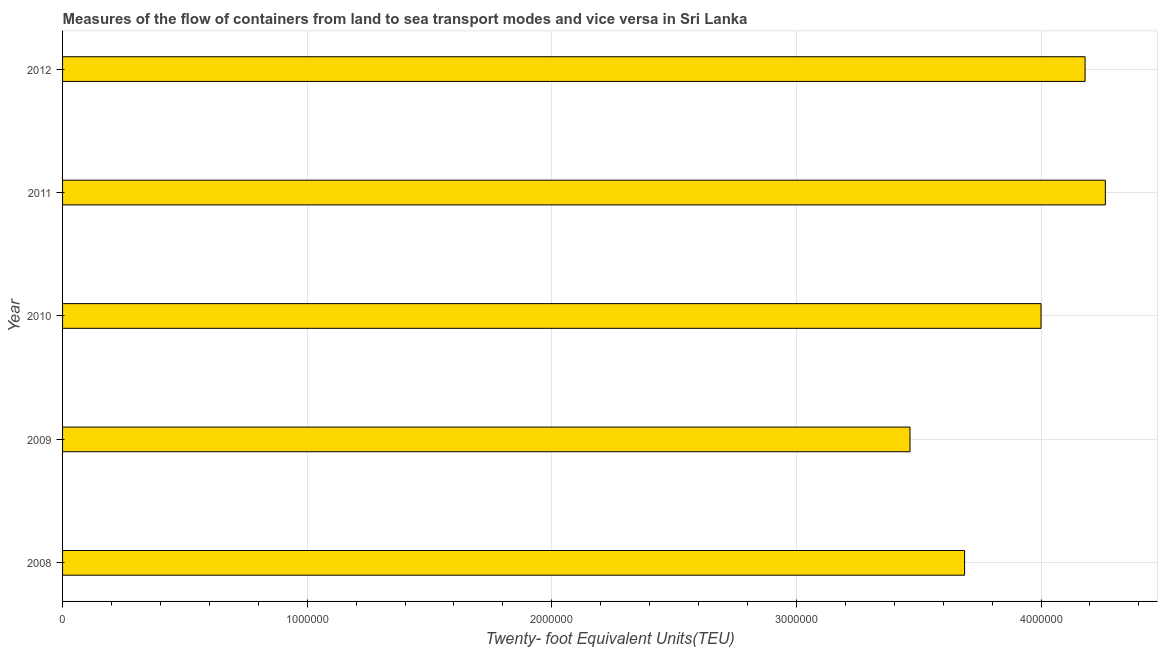What is the title of the graph?
Make the answer very short. Measures of the flow of containers from land to sea transport modes and vice versa in Sri Lanka. What is the label or title of the X-axis?
Give a very brief answer. Twenty- foot Equivalent Units(TEU). What is the label or title of the Y-axis?
Offer a terse response. Year. What is the container port traffic in 2009?
Make the answer very short. 3.46e+06. Across all years, what is the maximum container port traffic?
Your response must be concise. 4.26e+06. Across all years, what is the minimum container port traffic?
Make the answer very short. 3.46e+06. What is the sum of the container port traffic?
Your response must be concise. 1.96e+07. What is the difference between the container port traffic in 2008 and 2011?
Make the answer very short. -5.75e+05. What is the average container port traffic per year?
Your answer should be compact. 3.92e+06. What is the median container port traffic?
Provide a short and direct response. 4.00e+06. In how many years, is the container port traffic greater than 3600000 TEU?
Keep it short and to the point. 4. Do a majority of the years between 2008 and 2011 (inclusive) have container port traffic greater than 200000 TEU?
Offer a terse response. Yes. What is the ratio of the container port traffic in 2009 to that in 2010?
Your response must be concise. 0.87. Is the container port traffic in 2009 less than that in 2011?
Make the answer very short. Yes. What is the difference between the highest and the second highest container port traffic?
Provide a short and direct response. 8.29e+04. Is the sum of the container port traffic in 2008 and 2012 greater than the maximum container port traffic across all years?
Make the answer very short. Yes. What is the difference between the highest and the lowest container port traffic?
Your answer should be compact. 7.99e+05. In how many years, is the container port traffic greater than the average container port traffic taken over all years?
Your response must be concise. 3. Are all the bars in the graph horizontal?
Give a very brief answer. Yes. Are the values on the major ticks of X-axis written in scientific E-notation?
Make the answer very short. No. What is the Twenty- foot Equivalent Units(TEU) of 2008?
Provide a succinct answer. 3.69e+06. What is the Twenty- foot Equivalent Units(TEU) of 2009?
Offer a very short reply. 3.46e+06. What is the Twenty- foot Equivalent Units(TEU) in 2010?
Give a very brief answer. 4.00e+06. What is the Twenty- foot Equivalent Units(TEU) of 2011?
Keep it short and to the point. 4.26e+06. What is the Twenty- foot Equivalent Units(TEU) in 2012?
Ensure brevity in your answer.  4.18e+06. What is the difference between the Twenty- foot Equivalent Units(TEU) in 2008 and 2009?
Your answer should be very brief. 2.23e+05. What is the difference between the Twenty- foot Equivalent Units(TEU) in 2008 and 2010?
Provide a succinct answer. -3.13e+05. What is the difference between the Twenty- foot Equivalent Units(TEU) in 2008 and 2011?
Offer a very short reply. -5.75e+05. What is the difference between the Twenty- foot Equivalent Units(TEU) in 2008 and 2012?
Provide a succinct answer. -4.93e+05. What is the difference between the Twenty- foot Equivalent Units(TEU) in 2009 and 2010?
Your response must be concise. -5.36e+05. What is the difference between the Twenty- foot Equivalent Units(TEU) in 2009 and 2011?
Your answer should be very brief. -7.99e+05. What is the difference between the Twenty- foot Equivalent Units(TEU) in 2009 and 2012?
Keep it short and to the point. -7.16e+05. What is the difference between the Twenty- foot Equivalent Units(TEU) in 2010 and 2011?
Your response must be concise. -2.63e+05. What is the difference between the Twenty- foot Equivalent Units(TEU) in 2010 and 2012?
Your answer should be compact. -1.80e+05. What is the difference between the Twenty- foot Equivalent Units(TEU) in 2011 and 2012?
Offer a terse response. 8.29e+04. What is the ratio of the Twenty- foot Equivalent Units(TEU) in 2008 to that in 2009?
Offer a very short reply. 1.06. What is the ratio of the Twenty- foot Equivalent Units(TEU) in 2008 to that in 2010?
Ensure brevity in your answer.  0.92. What is the ratio of the Twenty- foot Equivalent Units(TEU) in 2008 to that in 2011?
Your answer should be very brief. 0.86. What is the ratio of the Twenty- foot Equivalent Units(TEU) in 2008 to that in 2012?
Offer a terse response. 0.88. What is the ratio of the Twenty- foot Equivalent Units(TEU) in 2009 to that in 2010?
Give a very brief answer. 0.87. What is the ratio of the Twenty- foot Equivalent Units(TEU) in 2009 to that in 2011?
Provide a short and direct response. 0.81. What is the ratio of the Twenty- foot Equivalent Units(TEU) in 2009 to that in 2012?
Your answer should be compact. 0.83. What is the ratio of the Twenty- foot Equivalent Units(TEU) in 2010 to that in 2011?
Your answer should be very brief. 0.94. What is the ratio of the Twenty- foot Equivalent Units(TEU) in 2010 to that in 2012?
Offer a terse response. 0.96. 